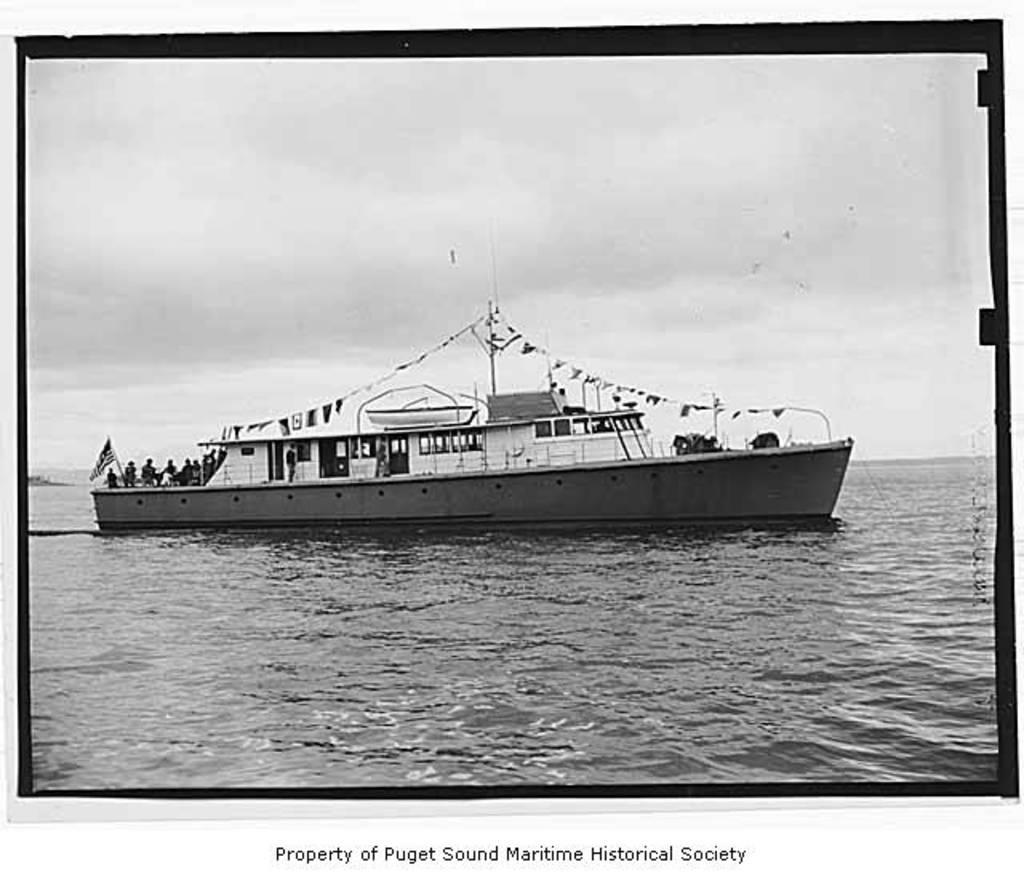<image>
Provide a brief description of the given image. White ship which is a property of Puget Sound Maritime Historical Society. 